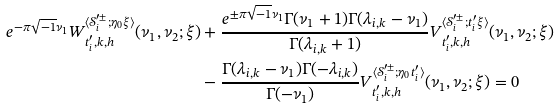Convert formula to latex. <formula><loc_0><loc_0><loc_500><loc_500>e ^ { - \pi \sqrt { - 1 } \nu _ { 1 } } W ^ { \langle \mathcal { S } ^ { \prime \pm } _ { i } ; \eta _ { 0 } \xi \rangle } _ { t ^ { \prime } _ { i } , k , h } ( \nu _ { 1 } , \nu _ { 2 } ; \xi ) & + \frac { e ^ { \pm \pi \sqrt { - 1 } \nu _ { 1 } } \Gamma ( \nu _ { 1 } + 1 ) \Gamma ( \lambda _ { i , k } - \nu _ { 1 } ) } { \Gamma ( \lambda _ { i , k } + 1 ) } V ^ { \langle \mathcal { S } ^ { \prime \pm } _ { i } ; t ^ { \prime } _ { i } \xi \rangle } _ { t ^ { \prime } _ { i } , k , h } ( \nu _ { 1 } , \nu _ { 2 } ; \xi ) \\ & - \frac { \Gamma ( \lambda _ { i , k } - \nu _ { 1 } ) \Gamma ( - \lambda _ { i , k } ) } { \Gamma ( - \nu _ { 1 } ) } V ^ { \langle \mathcal { S } ^ { \prime \pm } _ { i } ; \eta _ { 0 } t ^ { \prime } _ { i } \rangle } _ { t ^ { \prime } _ { i } , k , h } ( \nu _ { 1 } , \nu _ { 2 } ; \xi ) = 0</formula> 